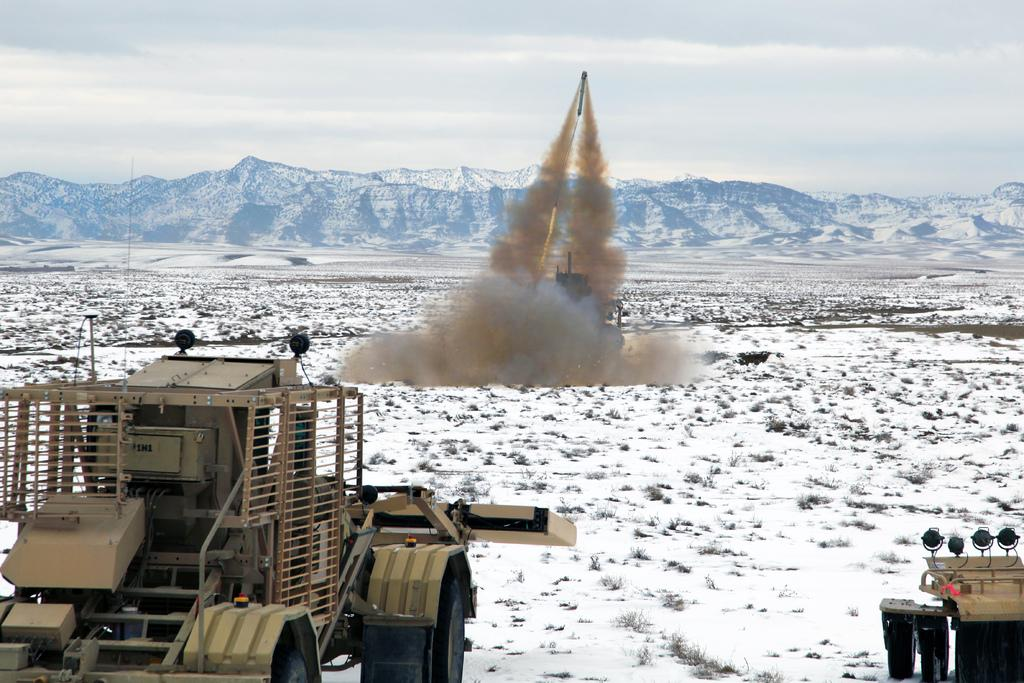What is the main feature of the landscape in the image? The image shows a place surrounded by ice mountains. What is the condition of the ground in the image? There is snow on the ground in the image. What type of vehicles can be seen on the ground? Vehicles are visible on the ground in the image. What is happening in the sky in the image? A missile is being launched into the sky in the image. What is the color of the sky in the image? The sky is blue in the image. What type of chalk is being used to draw on the ice mountains in the image? There is no chalk or drawing activity present in the image. What type of war is being depicted in the image? The image does not depict any war or conflict; it shows a missile being launched into the sky. 